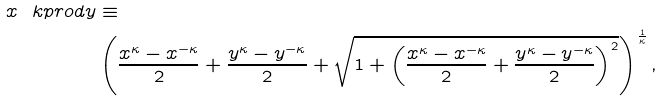<formula> <loc_0><loc_0><loc_500><loc_500>x \ k p r o d y & \equiv \\ & \left ( \frac { x ^ { \kappa } - x ^ { - \kappa } } { 2 } + \frac { y ^ { \kappa } - y ^ { - \kappa } } { 2 } + \sqrt { 1 + \left ( \frac { x ^ { \kappa } - x ^ { - \kappa } } { 2 } + \frac { y ^ { \kappa } - y ^ { - \kappa } } { 2 } \right ) ^ { 2 } } \right ) ^ { \frac { 1 } { \kappa } } ,</formula> 